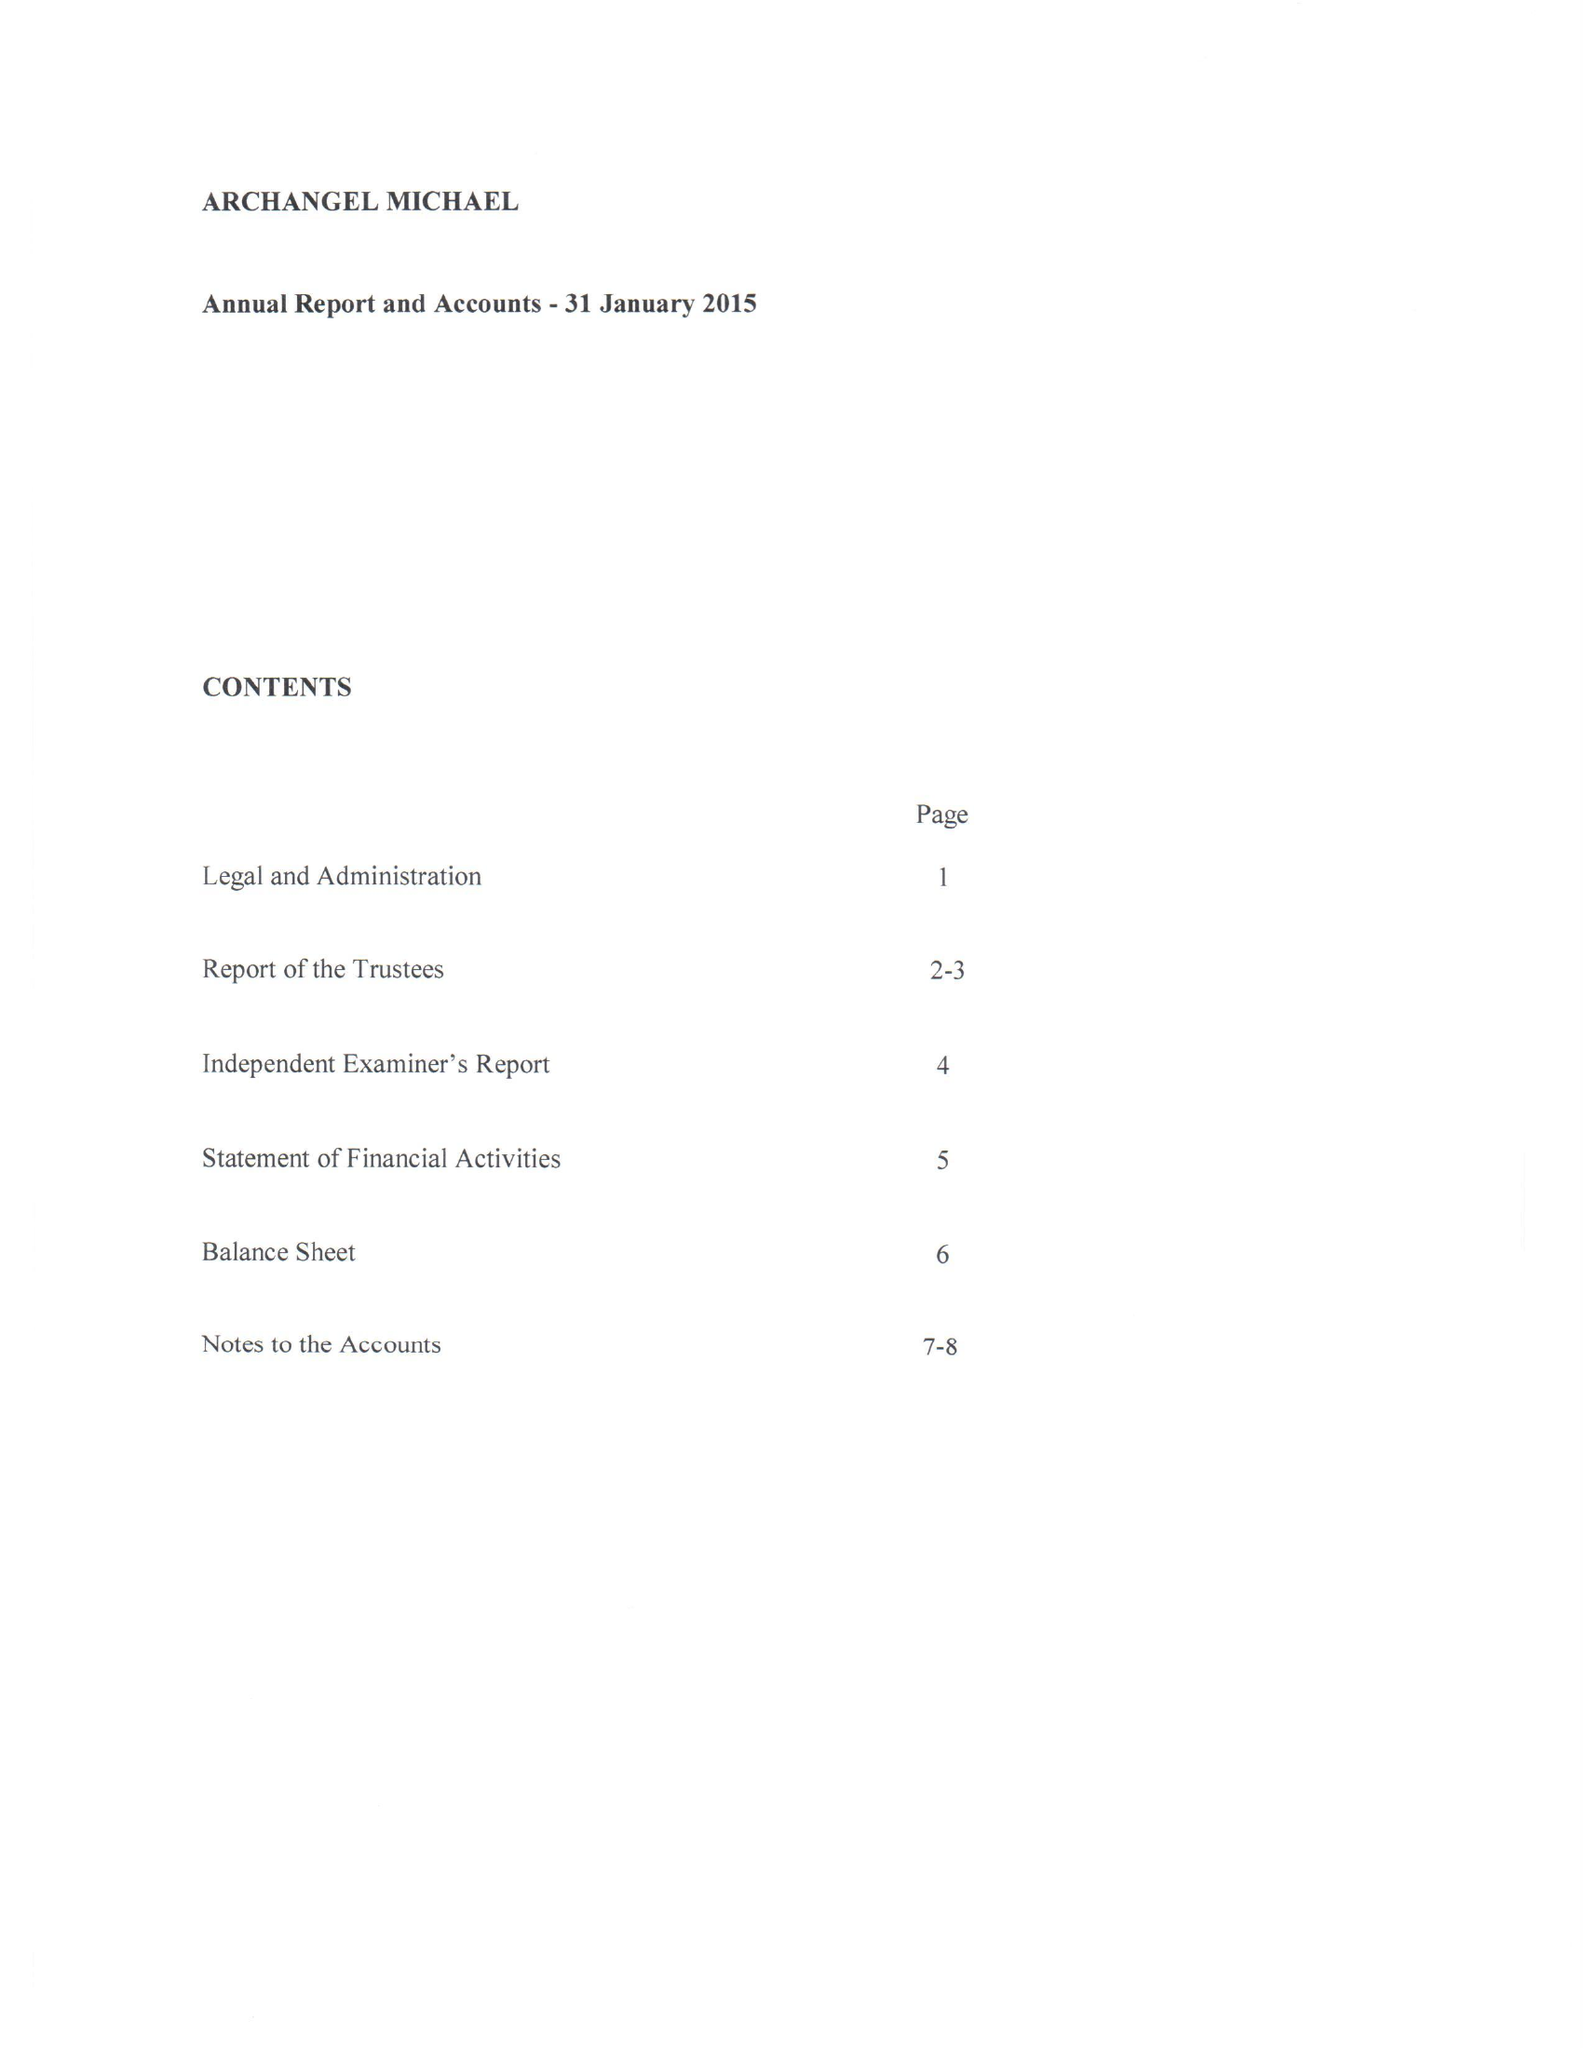What is the value for the report_date?
Answer the question using a single word or phrase. 2015-01-31 